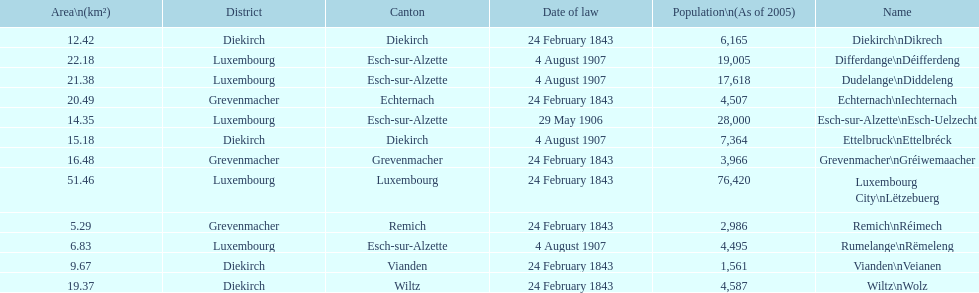How many diekirch districts also have diekirch as their canton? 2. 